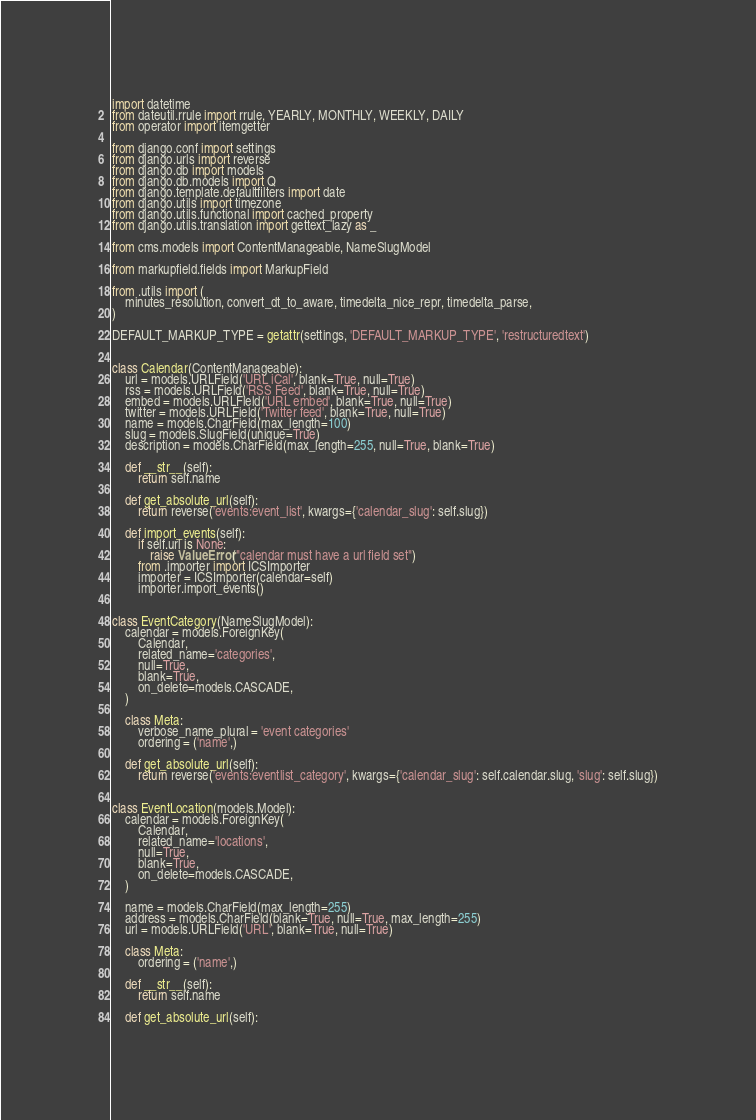Convert code to text. <code><loc_0><loc_0><loc_500><loc_500><_Python_>import datetime
from dateutil.rrule import rrule, YEARLY, MONTHLY, WEEKLY, DAILY
from operator import itemgetter

from django.conf import settings
from django.urls import reverse
from django.db import models
from django.db.models import Q
from django.template.defaultfilters import date
from django.utils import timezone
from django.utils.functional import cached_property
from django.utils.translation import gettext_lazy as _

from cms.models import ContentManageable, NameSlugModel

from markupfield.fields import MarkupField

from .utils import (
    minutes_resolution, convert_dt_to_aware, timedelta_nice_repr, timedelta_parse,
)

DEFAULT_MARKUP_TYPE = getattr(settings, 'DEFAULT_MARKUP_TYPE', 'restructuredtext')


class Calendar(ContentManageable):
    url = models.URLField('URL iCal', blank=True, null=True)
    rss = models.URLField('RSS Feed', blank=True, null=True)
    embed = models.URLField('URL embed', blank=True, null=True)
    twitter = models.URLField('Twitter feed', blank=True, null=True)
    name = models.CharField(max_length=100)
    slug = models.SlugField(unique=True)
    description = models.CharField(max_length=255, null=True, blank=True)

    def __str__(self):
        return self.name

    def get_absolute_url(self):
        return reverse('events:event_list', kwargs={'calendar_slug': self.slug})

    def import_events(self):
        if self.url is None:
            raise ValueError("calendar must have a url field set")
        from .importer import ICSImporter
        importer = ICSImporter(calendar=self)
        importer.import_events()


class EventCategory(NameSlugModel):
    calendar = models.ForeignKey(
        Calendar,
        related_name='categories',
        null=True,
        blank=True,
        on_delete=models.CASCADE,
    )

    class Meta:
        verbose_name_plural = 'event categories'
        ordering = ('name',)

    def get_absolute_url(self):
        return reverse('events:eventlist_category', kwargs={'calendar_slug': self.calendar.slug, 'slug': self.slug})


class EventLocation(models.Model):
    calendar = models.ForeignKey(
        Calendar,
        related_name='locations',
        null=True,
        blank=True,
        on_delete=models.CASCADE,
    )

    name = models.CharField(max_length=255)
    address = models.CharField(blank=True, null=True, max_length=255)
    url = models.URLField('URL', blank=True, null=True)

    class Meta:
        ordering = ('name',)

    def __str__(self):
        return self.name

    def get_absolute_url(self):</code> 